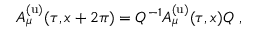Convert formula to latex. <formula><loc_0><loc_0><loc_500><loc_500>A _ { \mu } ^ { ( u ) } ( \tau , x + 2 \pi ) = Q ^ { - 1 } A _ { \mu } ^ { ( u ) } ( \tau , x ) Q ,</formula> 